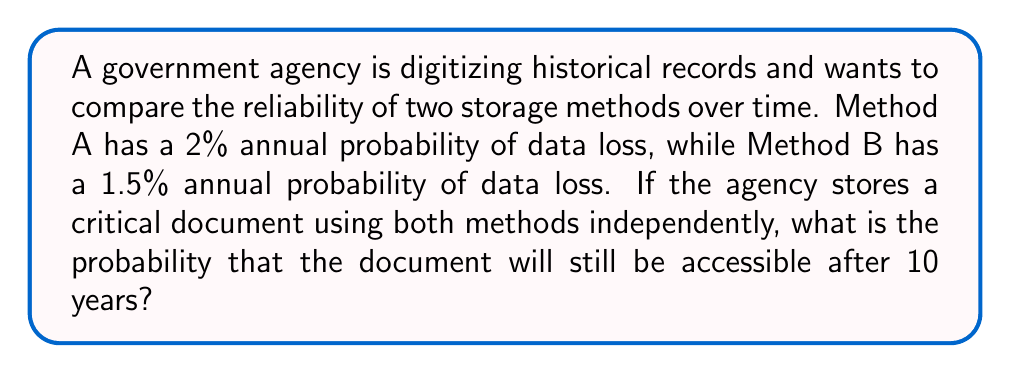Teach me how to tackle this problem. Let's approach this step-by-step:

1) First, we need to calculate the probability of data survival for each method over 10 years.

2) For Method A:
   Probability of survival for 1 year = 1 - 0.02 = 0.98
   Probability of survival for 10 years = $0.98^{10}$

3) For Method B:
   Probability of survival for 1 year = 1 - 0.015 = 0.985
   Probability of survival for 10 years = $0.985^{10}$

4) The document will be accessible if it survives in at least one of the methods. To find this, we can calculate the probability that it doesn't survive in either method and subtract from 1.

5) Probability of loss in both methods:
   $P(\text{loss in both}) = (1 - 0.98^{10}) \times (1 - 0.985^{10})$

6) Therefore, the probability of the document being accessible is:
   $P(\text{accessible}) = 1 - P(\text{loss in both})$
   $= 1 - (1 - 0.98^{10}) \times (1 - 0.985^{10})$

7) Let's calculate:
   $0.98^{10} \approx 0.8171$
   $0.985^{10} \approx 0.8599$

8) Substituting:
   $P(\text{accessible}) = 1 - (1 - 0.8171) \times (1 - 0.8599)$
   $= 1 - 0.1829 \times 0.1401$
   $= 1 - 0.0256$
   $= 0.9744$

9) Converting to a percentage: 0.9744 * 100 = 97.44%
Answer: 97.44% 